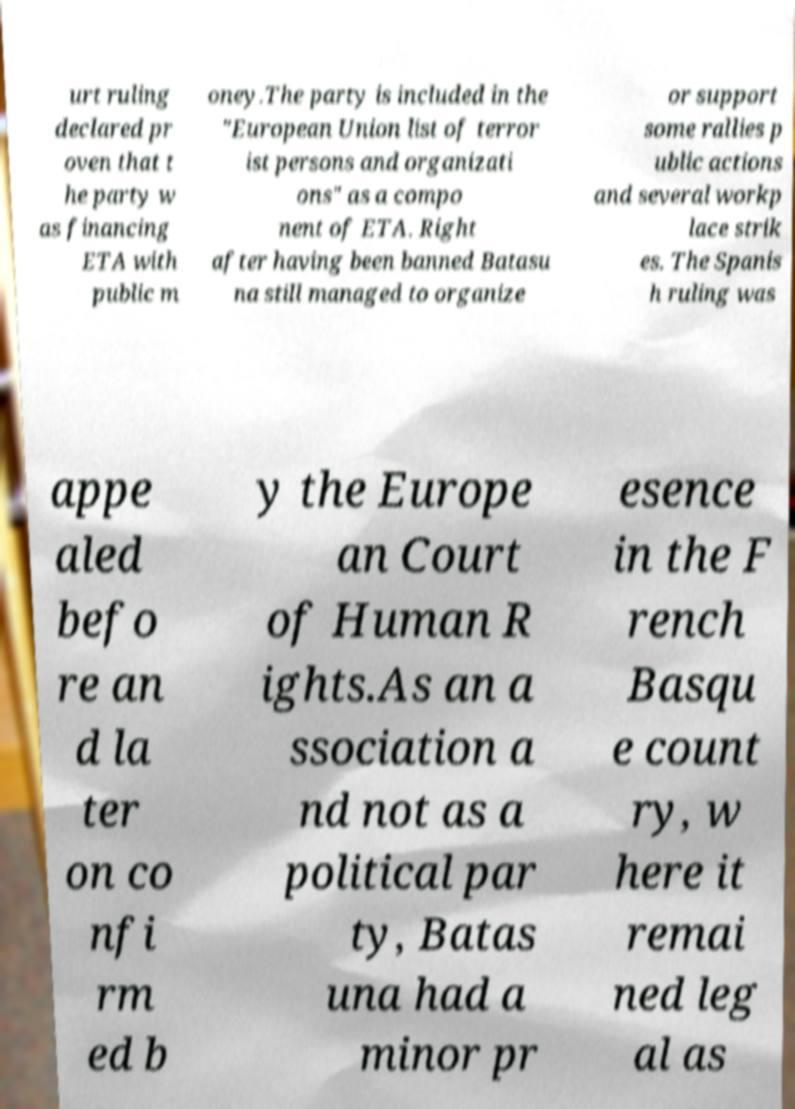For documentation purposes, I need the text within this image transcribed. Could you provide that? urt ruling declared pr oven that t he party w as financing ETA with public m oney.The party is included in the "European Union list of terror ist persons and organizati ons" as a compo nent of ETA. Right after having been banned Batasu na still managed to organize or support some rallies p ublic actions and several workp lace strik es. The Spanis h ruling was appe aled befo re an d la ter on co nfi rm ed b y the Europe an Court of Human R ights.As an a ssociation a nd not as a political par ty, Batas una had a minor pr esence in the F rench Basqu e count ry, w here it remai ned leg al as 